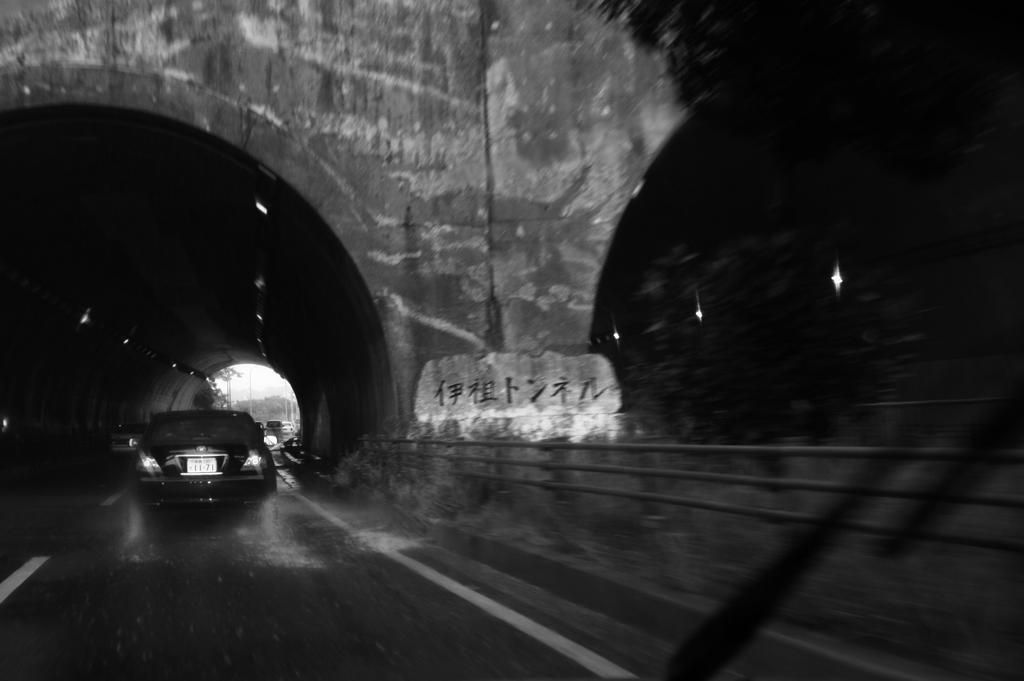Can you describe this image briefly? In the picture we can see a road under the tunnel, on the road we can see some vehicles and beside it also we can see another tunnel with lights and a tree near it. 